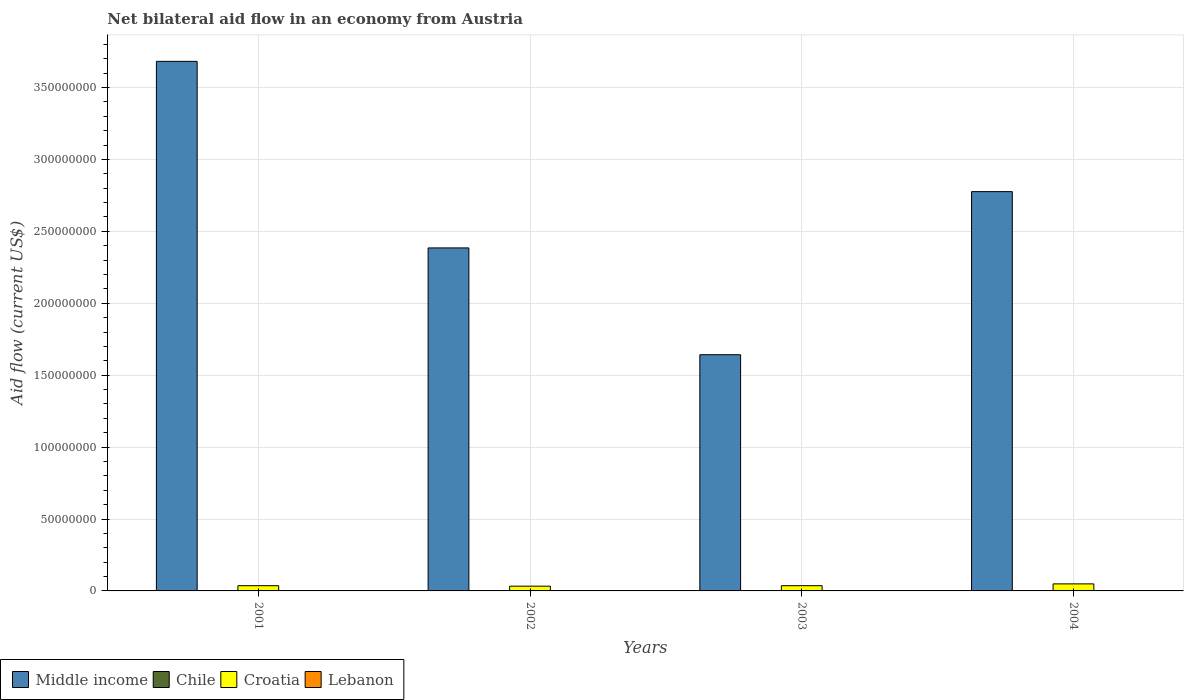How many groups of bars are there?
Offer a terse response. 4. Are the number of bars per tick equal to the number of legend labels?
Keep it short and to the point. Yes. Are the number of bars on each tick of the X-axis equal?
Give a very brief answer. Yes. How many bars are there on the 4th tick from the right?
Ensure brevity in your answer.  4. In how many cases, is the number of bars for a given year not equal to the number of legend labels?
Provide a short and direct response. 0. What is the net bilateral aid flow in Croatia in 2003?
Ensure brevity in your answer.  3.63e+06. Across all years, what is the minimum net bilateral aid flow in Croatia?
Give a very brief answer. 3.31e+06. What is the total net bilateral aid flow in Croatia in the graph?
Provide a succinct answer. 1.55e+07. What is the difference between the net bilateral aid flow in Middle income in 2002 and that in 2004?
Your response must be concise. -3.92e+07. What is the average net bilateral aid flow in Lebanon per year?
Offer a terse response. 1.28e+05. In the year 2003, what is the difference between the net bilateral aid flow in Lebanon and net bilateral aid flow in Croatia?
Your response must be concise. -3.42e+06. What is the ratio of the net bilateral aid flow in Croatia in 2002 to that in 2004?
Your answer should be compact. 0.68. Is the net bilateral aid flow in Croatia in 2001 less than that in 2002?
Give a very brief answer. No. What is the difference between the highest and the second highest net bilateral aid flow in Croatia?
Give a very brief answer. 1.26e+06. What is the difference between the highest and the lowest net bilateral aid flow in Chile?
Provide a short and direct response. 1.80e+05. In how many years, is the net bilateral aid flow in Chile greater than the average net bilateral aid flow in Chile taken over all years?
Provide a succinct answer. 1. Is the sum of the net bilateral aid flow in Croatia in 2003 and 2004 greater than the maximum net bilateral aid flow in Chile across all years?
Make the answer very short. Yes. Is it the case that in every year, the sum of the net bilateral aid flow in Chile and net bilateral aid flow in Lebanon is greater than the sum of net bilateral aid flow in Middle income and net bilateral aid flow in Croatia?
Provide a succinct answer. No. What does the 3rd bar from the left in 2004 represents?
Your response must be concise. Croatia. Are all the bars in the graph horizontal?
Give a very brief answer. No. Does the graph contain grids?
Your answer should be very brief. Yes. Where does the legend appear in the graph?
Your answer should be very brief. Bottom left. How many legend labels are there?
Your answer should be very brief. 4. What is the title of the graph?
Make the answer very short. Net bilateral aid flow in an economy from Austria. Does "Czech Republic" appear as one of the legend labels in the graph?
Offer a very short reply. No. What is the Aid flow (current US$) in Middle income in 2001?
Ensure brevity in your answer.  3.68e+08. What is the Aid flow (current US$) of Chile in 2001?
Provide a short and direct response. 2.90e+05. What is the Aid flow (current US$) in Croatia in 2001?
Offer a very short reply. 3.63e+06. What is the Aid flow (current US$) of Middle income in 2002?
Ensure brevity in your answer.  2.38e+08. What is the Aid flow (current US$) of Chile in 2002?
Give a very brief answer. 1.60e+05. What is the Aid flow (current US$) of Croatia in 2002?
Offer a very short reply. 3.31e+06. What is the Aid flow (current US$) in Lebanon in 2002?
Give a very brief answer. 1.00e+05. What is the Aid flow (current US$) of Middle income in 2003?
Provide a succinct answer. 1.64e+08. What is the Aid flow (current US$) in Croatia in 2003?
Give a very brief answer. 3.63e+06. What is the Aid flow (current US$) in Lebanon in 2003?
Your response must be concise. 2.10e+05. What is the Aid flow (current US$) in Middle income in 2004?
Provide a short and direct response. 2.78e+08. What is the Aid flow (current US$) in Croatia in 2004?
Provide a short and direct response. 4.89e+06. Across all years, what is the maximum Aid flow (current US$) in Middle income?
Offer a very short reply. 3.68e+08. Across all years, what is the maximum Aid flow (current US$) in Chile?
Provide a succinct answer. 2.90e+05. Across all years, what is the maximum Aid flow (current US$) of Croatia?
Give a very brief answer. 4.89e+06. Across all years, what is the maximum Aid flow (current US$) of Lebanon?
Your answer should be very brief. 2.10e+05. Across all years, what is the minimum Aid flow (current US$) in Middle income?
Provide a succinct answer. 1.64e+08. Across all years, what is the minimum Aid flow (current US$) in Croatia?
Make the answer very short. 3.31e+06. What is the total Aid flow (current US$) in Middle income in the graph?
Provide a short and direct response. 1.05e+09. What is the total Aid flow (current US$) of Chile in the graph?
Provide a short and direct response. 7.40e+05. What is the total Aid flow (current US$) in Croatia in the graph?
Give a very brief answer. 1.55e+07. What is the total Aid flow (current US$) of Lebanon in the graph?
Your answer should be compact. 5.10e+05. What is the difference between the Aid flow (current US$) in Middle income in 2001 and that in 2002?
Your answer should be very brief. 1.30e+08. What is the difference between the Aid flow (current US$) in Middle income in 2001 and that in 2003?
Make the answer very short. 2.04e+08. What is the difference between the Aid flow (current US$) of Chile in 2001 and that in 2003?
Your answer should be compact. 1.10e+05. What is the difference between the Aid flow (current US$) of Lebanon in 2001 and that in 2003?
Offer a very short reply. -1.10e+05. What is the difference between the Aid flow (current US$) in Middle income in 2001 and that in 2004?
Your answer should be very brief. 9.06e+07. What is the difference between the Aid flow (current US$) in Chile in 2001 and that in 2004?
Your answer should be very brief. 1.80e+05. What is the difference between the Aid flow (current US$) of Croatia in 2001 and that in 2004?
Ensure brevity in your answer.  -1.26e+06. What is the difference between the Aid flow (current US$) of Middle income in 2002 and that in 2003?
Make the answer very short. 7.43e+07. What is the difference between the Aid flow (current US$) in Chile in 2002 and that in 2003?
Your response must be concise. -2.00e+04. What is the difference between the Aid flow (current US$) of Croatia in 2002 and that in 2003?
Your answer should be very brief. -3.20e+05. What is the difference between the Aid flow (current US$) in Middle income in 2002 and that in 2004?
Your response must be concise. -3.92e+07. What is the difference between the Aid flow (current US$) of Chile in 2002 and that in 2004?
Make the answer very short. 5.00e+04. What is the difference between the Aid flow (current US$) of Croatia in 2002 and that in 2004?
Provide a succinct answer. -1.58e+06. What is the difference between the Aid flow (current US$) in Middle income in 2003 and that in 2004?
Your answer should be compact. -1.13e+08. What is the difference between the Aid flow (current US$) in Croatia in 2003 and that in 2004?
Make the answer very short. -1.26e+06. What is the difference between the Aid flow (current US$) in Middle income in 2001 and the Aid flow (current US$) in Chile in 2002?
Make the answer very short. 3.68e+08. What is the difference between the Aid flow (current US$) in Middle income in 2001 and the Aid flow (current US$) in Croatia in 2002?
Ensure brevity in your answer.  3.65e+08. What is the difference between the Aid flow (current US$) of Middle income in 2001 and the Aid flow (current US$) of Lebanon in 2002?
Provide a short and direct response. 3.68e+08. What is the difference between the Aid flow (current US$) in Chile in 2001 and the Aid flow (current US$) in Croatia in 2002?
Keep it short and to the point. -3.02e+06. What is the difference between the Aid flow (current US$) of Chile in 2001 and the Aid flow (current US$) of Lebanon in 2002?
Offer a terse response. 1.90e+05. What is the difference between the Aid flow (current US$) in Croatia in 2001 and the Aid flow (current US$) in Lebanon in 2002?
Make the answer very short. 3.53e+06. What is the difference between the Aid flow (current US$) in Middle income in 2001 and the Aid flow (current US$) in Chile in 2003?
Ensure brevity in your answer.  3.68e+08. What is the difference between the Aid flow (current US$) of Middle income in 2001 and the Aid flow (current US$) of Croatia in 2003?
Keep it short and to the point. 3.65e+08. What is the difference between the Aid flow (current US$) in Middle income in 2001 and the Aid flow (current US$) in Lebanon in 2003?
Offer a terse response. 3.68e+08. What is the difference between the Aid flow (current US$) in Chile in 2001 and the Aid flow (current US$) in Croatia in 2003?
Your answer should be very brief. -3.34e+06. What is the difference between the Aid flow (current US$) of Croatia in 2001 and the Aid flow (current US$) of Lebanon in 2003?
Ensure brevity in your answer.  3.42e+06. What is the difference between the Aid flow (current US$) of Middle income in 2001 and the Aid flow (current US$) of Chile in 2004?
Give a very brief answer. 3.68e+08. What is the difference between the Aid flow (current US$) in Middle income in 2001 and the Aid flow (current US$) in Croatia in 2004?
Offer a terse response. 3.63e+08. What is the difference between the Aid flow (current US$) in Middle income in 2001 and the Aid flow (current US$) in Lebanon in 2004?
Offer a very short reply. 3.68e+08. What is the difference between the Aid flow (current US$) of Chile in 2001 and the Aid flow (current US$) of Croatia in 2004?
Provide a short and direct response. -4.60e+06. What is the difference between the Aid flow (current US$) of Croatia in 2001 and the Aid flow (current US$) of Lebanon in 2004?
Give a very brief answer. 3.53e+06. What is the difference between the Aid flow (current US$) of Middle income in 2002 and the Aid flow (current US$) of Chile in 2003?
Your answer should be compact. 2.38e+08. What is the difference between the Aid flow (current US$) in Middle income in 2002 and the Aid flow (current US$) in Croatia in 2003?
Provide a succinct answer. 2.35e+08. What is the difference between the Aid flow (current US$) in Middle income in 2002 and the Aid flow (current US$) in Lebanon in 2003?
Ensure brevity in your answer.  2.38e+08. What is the difference between the Aid flow (current US$) of Chile in 2002 and the Aid flow (current US$) of Croatia in 2003?
Give a very brief answer. -3.47e+06. What is the difference between the Aid flow (current US$) in Croatia in 2002 and the Aid flow (current US$) in Lebanon in 2003?
Your answer should be very brief. 3.10e+06. What is the difference between the Aid flow (current US$) of Middle income in 2002 and the Aid flow (current US$) of Chile in 2004?
Your answer should be very brief. 2.38e+08. What is the difference between the Aid flow (current US$) in Middle income in 2002 and the Aid flow (current US$) in Croatia in 2004?
Offer a very short reply. 2.34e+08. What is the difference between the Aid flow (current US$) of Middle income in 2002 and the Aid flow (current US$) of Lebanon in 2004?
Offer a very short reply. 2.38e+08. What is the difference between the Aid flow (current US$) in Chile in 2002 and the Aid flow (current US$) in Croatia in 2004?
Your response must be concise. -4.73e+06. What is the difference between the Aid flow (current US$) in Chile in 2002 and the Aid flow (current US$) in Lebanon in 2004?
Make the answer very short. 6.00e+04. What is the difference between the Aid flow (current US$) in Croatia in 2002 and the Aid flow (current US$) in Lebanon in 2004?
Your response must be concise. 3.21e+06. What is the difference between the Aid flow (current US$) of Middle income in 2003 and the Aid flow (current US$) of Chile in 2004?
Offer a very short reply. 1.64e+08. What is the difference between the Aid flow (current US$) in Middle income in 2003 and the Aid flow (current US$) in Croatia in 2004?
Your answer should be compact. 1.59e+08. What is the difference between the Aid flow (current US$) of Middle income in 2003 and the Aid flow (current US$) of Lebanon in 2004?
Keep it short and to the point. 1.64e+08. What is the difference between the Aid flow (current US$) in Chile in 2003 and the Aid flow (current US$) in Croatia in 2004?
Your response must be concise. -4.71e+06. What is the difference between the Aid flow (current US$) in Chile in 2003 and the Aid flow (current US$) in Lebanon in 2004?
Offer a terse response. 8.00e+04. What is the difference between the Aid flow (current US$) of Croatia in 2003 and the Aid flow (current US$) of Lebanon in 2004?
Provide a succinct answer. 3.53e+06. What is the average Aid flow (current US$) of Middle income per year?
Provide a succinct answer. 2.62e+08. What is the average Aid flow (current US$) in Chile per year?
Keep it short and to the point. 1.85e+05. What is the average Aid flow (current US$) in Croatia per year?
Offer a very short reply. 3.86e+06. What is the average Aid flow (current US$) of Lebanon per year?
Offer a terse response. 1.28e+05. In the year 2001, what is the difference between the Aid flow (current US$) in Middle income and Aid flow (current US$) in Chile?
Offer a terse response. 3.68e+08. In the year 2001, what is the difference between the Aid flow (current US$) in Middle income and Aid flow (current US$) in Croatia?
Ensure brevity in your answer.  3.65e+08. In the year 2001, what is the difference between the Aid flow (current US$) of Middle income and Aid flow (current US$) of Lebanon?
Your response must be concise. 3.68e+08. In the year 2001, what is the difference between the Aid flow (current US$) of Chile and Aid flow (current US$) of Croatia?
Your answer should be very brief. -3.34e+06. In the year 2001, what is the difference between the Aid flow (current US$) in Chile and Aid flow (current US$) in Lebanon?
Your response must be concise. 1.90e+05. In the year 2001, what is the difference between the Aid flow (current US$) of Croatia and Aid flow (current US$) of Lebanon?
Give a very brief answer. 3.53e+06. In the year 2002, what is the difference between the Aid flow (current US$) in Middle income and Aid flow (current US$) in Chile?
Provide a succinct answer. 2.38e+08. In the year 2002, what is the difference between the Aid flow (current US$) in Middle income and Aid flow (current US$) in Croatia?
Offer a very short reply. 2.35e+08. In the year 2002, what is the difference between the Aid flow (current US$) of Middle income and Aid flow (current US$) of Lebanon?
Give a very brief answer. 2.38e+08. In the year 2002, what is the difference between the Aid flow (current US$) in Chile and Aid flow (current US$) in Croatia?
Your response must be concise. -3.15e+06. In the year 2002, what is the difference between the Aid flow (current US$) of Chile and Aid flow (current US$) of Lebanon?
Your response must be concise. 6.00e+04. In the year 2002, what is the difference between the Aid flow (current US$) of Croatia and Aid flow (current US$) of Lebanon?
Provide a succinct answer. 3.21e+06. In the year 2003, what is the difference between the Aid flow (current US$) in Middle income and Aid flow (current US$) in Chile?
Your answer should be compact. 1.64e+08. In the year 2003, what is the difference between the Aid flow (current US$) in Middle income and Aid flow (current US$) in Croatia?
Offer a terse response. 1.61e+08. In the year 2003, what is the difference between the Aid flow (current US$) in Middle income and Aid flow (current US$) in Lebanon?
Provide a short and direct response. 1.64e+08. In the year 2003, what is the difference between the Aid flow (current US$) in Chile and Aid flow (current US$) in Croatia?
Make the answer very short. -3.45e+06. In the year 2003, what is the difference between the Aid flow (current US$) in Croatia and Aid flow (current US$) in Lebanon?
Keep it short and to the point. 3.42e+06. In the year 2004, what is the difference between the Aid flow (current US$) in Middle income and Aid flow (current US$) in Chile?
Your answer should be very brief. 2.78e+08. In the year 2004, what is the difference between the Aid flow (current US$) of Middle income and Aid flow (current US$) of Croatia?
Offer a very short reply. 2.73e+08. In the year 2004, what is the difference between the Aid flow (current US$) in Middle income and Aid flow (current US$) in Lebanon?
Your answer should be very brief. 2.78e+08. In the year 2004, what is the difference between the Aid flow (current US$) in Chile and Aid flow (current US$) in Croatia?
Your response must be concise. -4.78e+06. In the year 2004, what is the difference between the Aid flow (current US$) of Chile and Aid flow (current US$) of Lebanon?
Your answer should be very brief. 10000. In the year 2004, what is the difference between the Aid flow (current US$) of Croatia and Aid flow (current US$) of Lebanon?
Your answer should be very brief. 4.79e+06. What is the ratio of the Aid flow (current US$) in Middle income in 2001 to that in 2002?
Your answer should be compact. 1.54. What is the ratio of the Aid flow (current US$) in Chile in 2001 to that in 2002?
Provide a succinct answer. 1.81. What is the ratio of the Aid flow (current US$) of Croatia in 2001 to that in 2002?
Your answer should be very brief. 1.1. What is the ratio of the Aid flow (current US$) of Middle income in 2001 to that in 2003?
Make the answer very short. 2.24. What is the ratio of the Aid flow (current US$) in Chile in 2001 to that in 2003?
Ensure brevity in your answer.  1.61. What is the ratio of the Aid flow (current US$) of Lebanon in 2001 to that in 2003?
Your answer should be very brief. 0.48. What is the ratio of the Aid flow (current US$) in Middle income in 2001 to that in 2004?
Your answer should be very brief. 1.33. What is the ratio of the Aid flow (current US$) in Chile in 2001 to that in 2004?
Your response must be concise. 2.64. What is the ratio of the Aid flow (current US$) in Croatia in 2001 to that in 2004?
Your response must be concise. 0.74. What is the ratio of the Aid flow (current US$) in Lebanon in 2001 to that in 2004?
Ensure brevity in your answer.  1. What is the ratio of the Aid flow (current US$) of Middle income in 2002 to that in 2003?
Offer a very short reply. 1.45. What is the ratio of the Aid flow (current US$) in Croatia in 2002 to that in 2003?
Ensure brevity in your answer.  0.91. What is the ratio of the Aid flow (current US$) of Lebanon in 2002 to that in 2003?
Give a very brief answer. 0.48. What is the ratio of the Aid flow (current US$) of Middle income in 2002 to that in 2004?
Keep it short and to the point. 0.86. What is the ratio of the Aid flow (current US$) of Chile in 2002 to that in 2004?
Give a very brief answer. 1.45. What is the ratio of the Aid flow (current US$) in Croatia in 2002 to that in 2004?
Your answer should be compact. 0.68. What is the ratio of the Aid flow (current US$) in Lebanon in 2002 to that in 2004?
Your answer should be very brief. 1. What is the ratio of the Aid flow (current US$) in Middle income in 2003 to that in 2004?
Ensure brevity in your answer.  0.59. What is the ratio of the Aid flow (current US$) of Chile in 2003 to that in 2004?
Offer a very short reply. 1.64. What is the ratio of the Aid flow (current US$) of Croatia in 2003 to that in 2004?
Your answer should be very brief. 0.74. What is the difference between the highest and the second highest Aid flow (current US$) of Middle income?
Ensure brevity in your answer.  9.06e+07. What is the difference between the highest and the second highest Aid flow (current US$) in Chile?
Ensure brevity in your answer.  1.10e+05. What is the difference between the highest and the second highest Aid flow (current US$) of Croatia?
Give a very brief answer. 1.26e+06. What is the difference between the highest and the second highest Aid flow (current US$) of Lebanon?
Your response must be concise. 1.10e+05. What is the difference between the highest and the lowest Aid flow (current US$) of Middle income?
Give a very brief answer. 2.04e+08. What is the difference between the highest and the lowest Aid flow (current US$) of Chile?
Your answer should be compact. 1.80e+05. What is the difference between the highest and the lowest Aid flow (current US$) of Croatia?
Your response must be concise. 1.58e+06. 